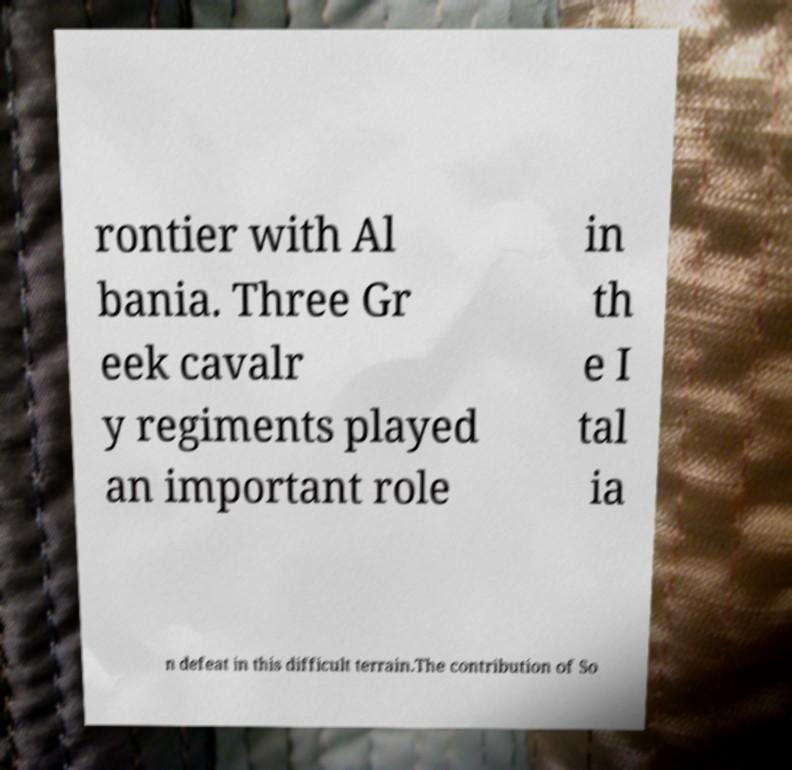Could you extract and type out the text from this image? rontier with Al bania. Three Gr eek cavalr y regiments played an important role in th e I tal ia n defeat in this difficult terrain.The contribution of So 